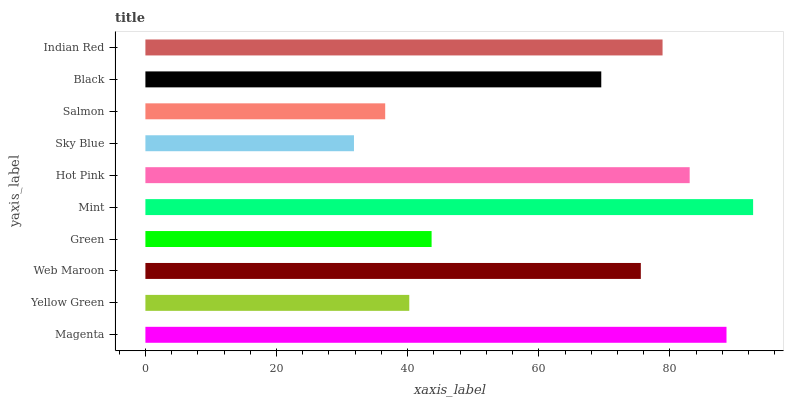Is Sky Blue the minimum?
Answer yes or no. Yes. Is Mint the maximum?
Answer yes or no. Yes. Is Yellow Green the minimum?
Answer yes or no. No. Is Yellow Green the maximum?
Answer yes or no. No. Is Magenta greater than Yellow Green?
Answer yes or no. Yes. Is Yellow Green less than Magenta?
Answer yes or no. Yes. Is Yellow Green greater than Magenta?
Answer yes or no. No. Is Magenta less than Yellow Green?
Answer yes or no. No. Is Web Maroon the high median?
Answer yes or no. Yes. Is Black the low median?
Answer yes or no. Yes. Is Mint the high median?
Answer yes or no. No. Is Green the low median?
Answer yes or no. No. 